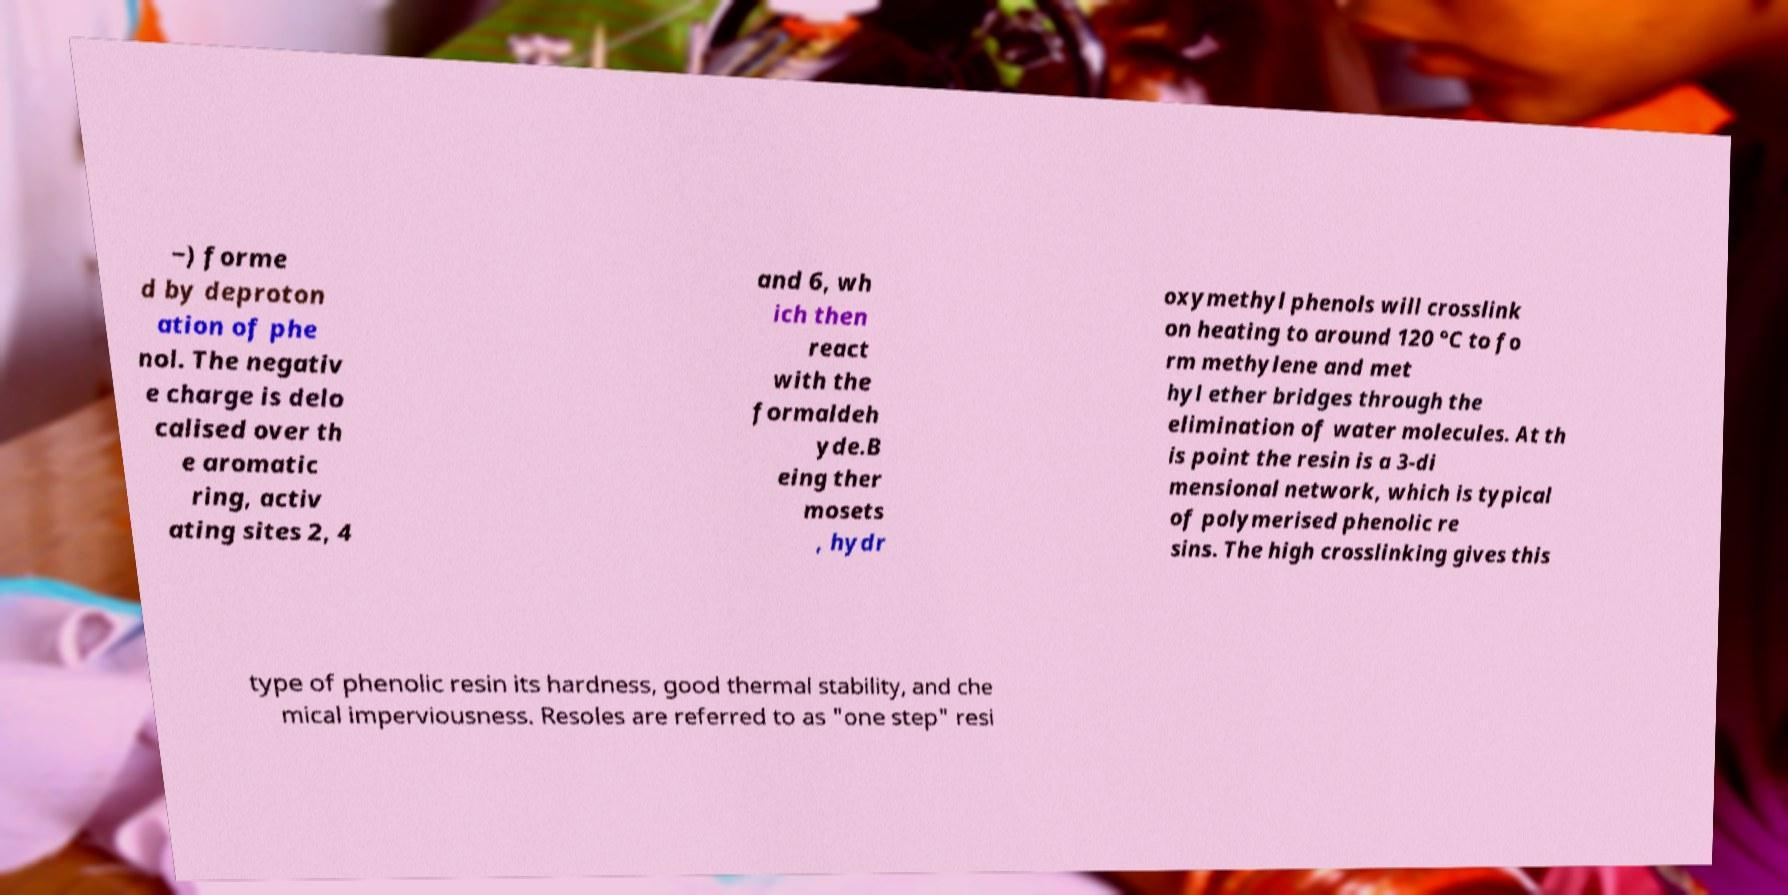Could you extract and type out the text from this image? −) forme d by deproton ation of phe nol. The negativ e charge is delo calised over th e aromatic ring, activ ating sites 2, 4 and 6, wh ich then react with the formaldeh yde.B eing ther mosets , hydr oxymethyl phenols will crosslink on heating to around 120 °C to fo rm methylene and met hyl ether bridges through the elimination of water molecules. At th is point the resin is a 3-di mensional network, which is typical of polymerised phenolic re sins. The high crosslinking gives this type of phenolic resin its hardness, good thermal stability, and che mical imperviousness. Resoles are referred to as "one step" resi 